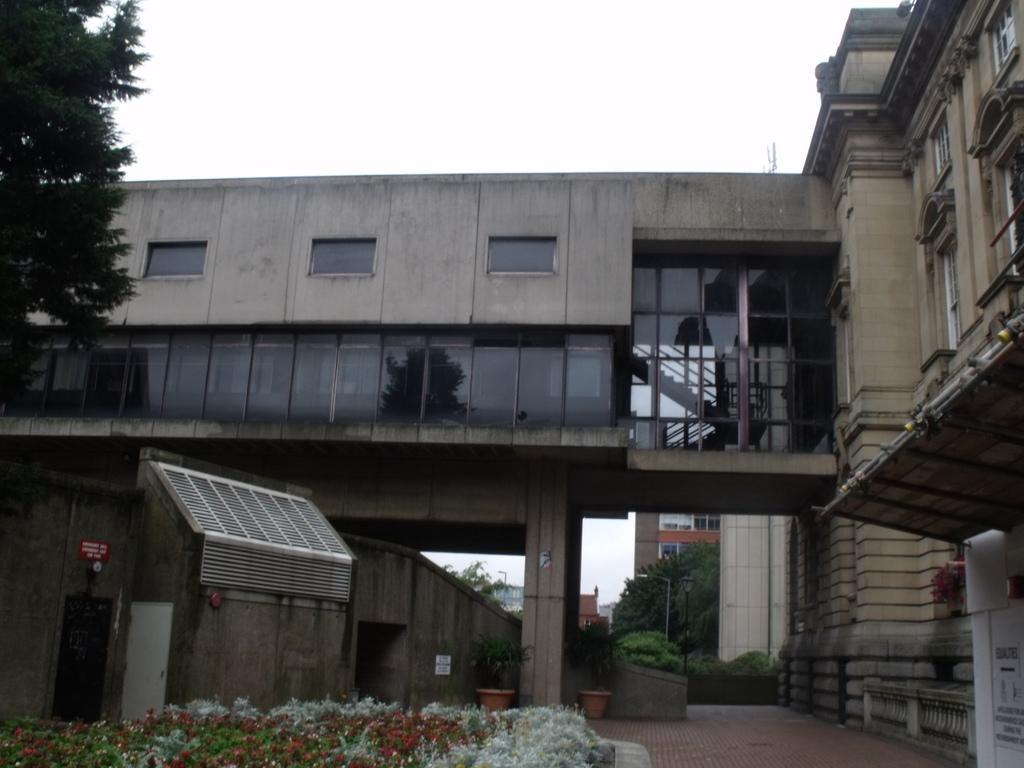What type of structure is visible in the image? There is a building in the image. What is located in front of the building? Plants and trees are present in front of the building. What can be seen above the building? The sky is visible above the building. How many birds are sitting on the building in the image? There are no birds visible on the building in the image. 